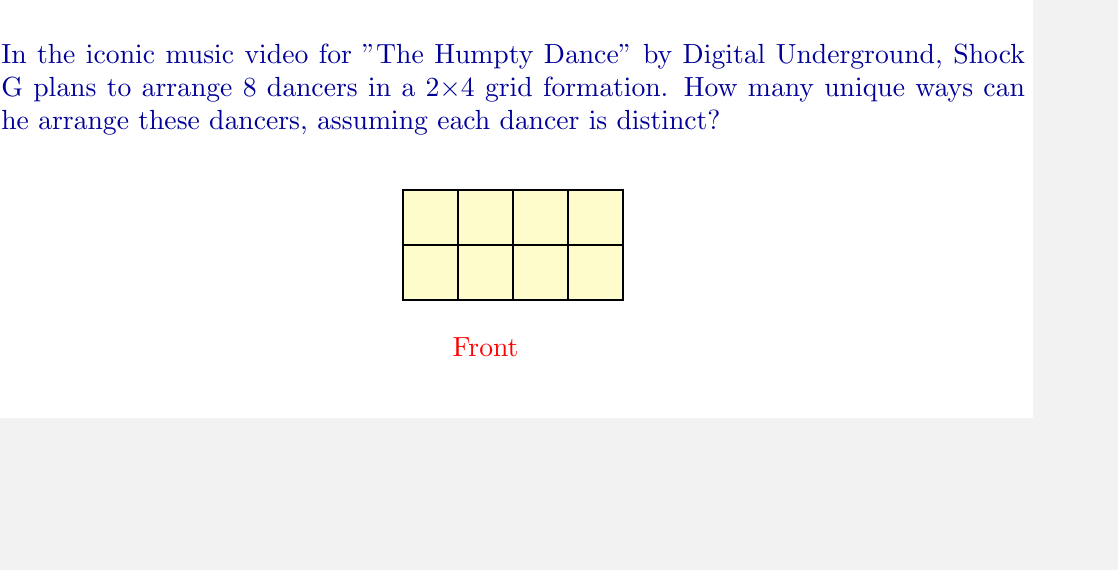What is the answer to this math problem? Let's approach this step-by-step:

1) We have 8 distinct dancers, and we need to place them in 8 positions (2 rows x 4 columns).

2) This is a permutation problem, as the order matters (each dancer is distinct) and we're using all 8 dancers.

3) The number of ways to arrange n distinct objects is given by the factorial of n, denoted as n!

4) In this case, n = 8, so we need to calculate 8!

5) Let's expand this:
   $$8! = 8 \times 7 \times 6 \times 5 \times 4 \times 3 \times 2 \times 1$$

6) Computing this:
   $$8! = 40,320$$

Therefore, Shock G can arrange the 8 dancers in 40,320 unique ways.
Answer: $40,320$ 